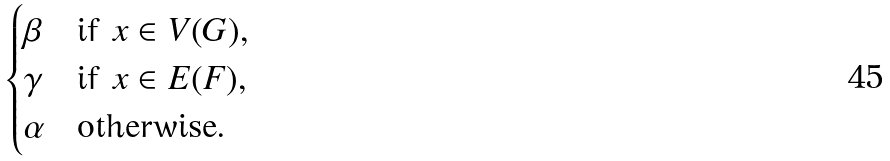<formula> <loc_0><loc_0><loc_500><loc_500>\begin{cases} \beta & \text {if $x\in V(G)$,} \\ \gamma & \text {if $x\in E(F)$,} \\ \alpha & \text {otherwise.} \end{cases}</formula> 